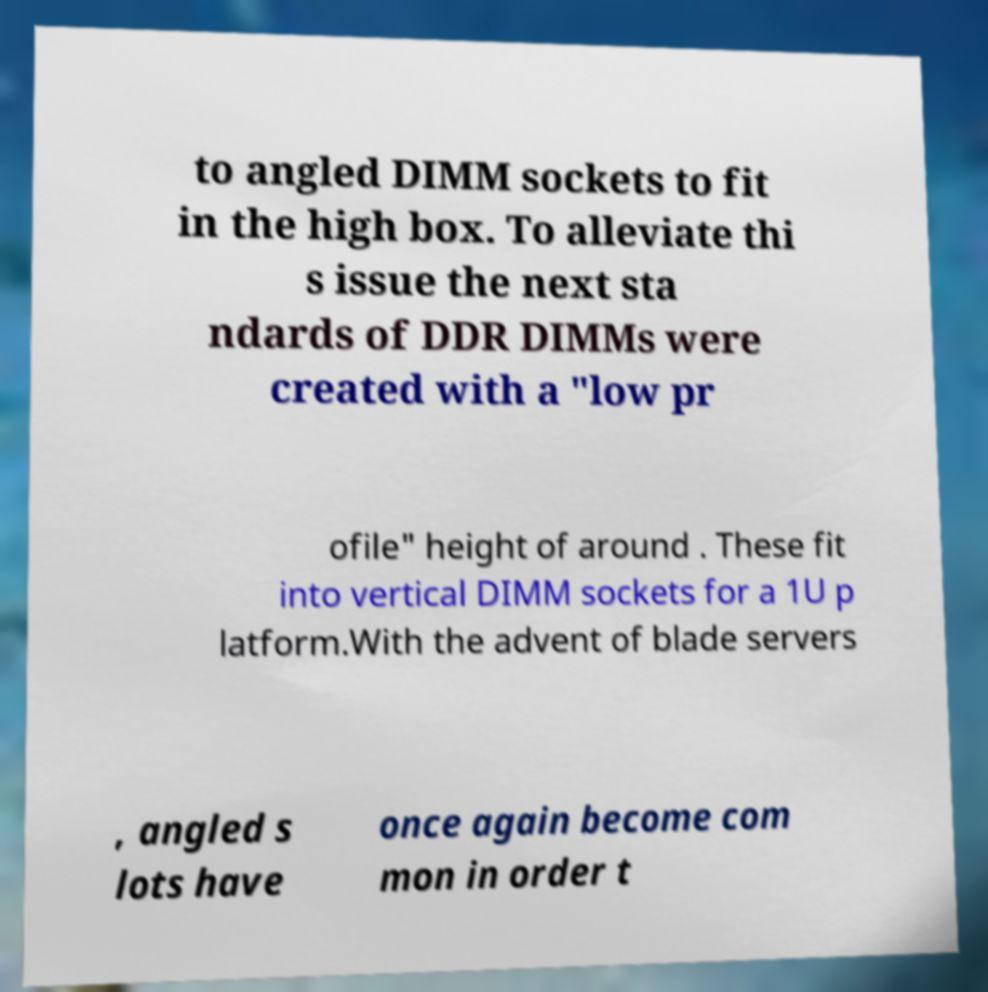Could you assist in decoding the text presented in this image and type it out clearly? to angled DIMM sockets to fit in the high box. To alleviate thi s issue the next sta ndards of DDR DIMMs were created with a "low pr ofile" height of around . These fit into vertical DIMM sockets for a 1U p latform.With the advent of blade servers , angled s lots have once again become com mon in order t 